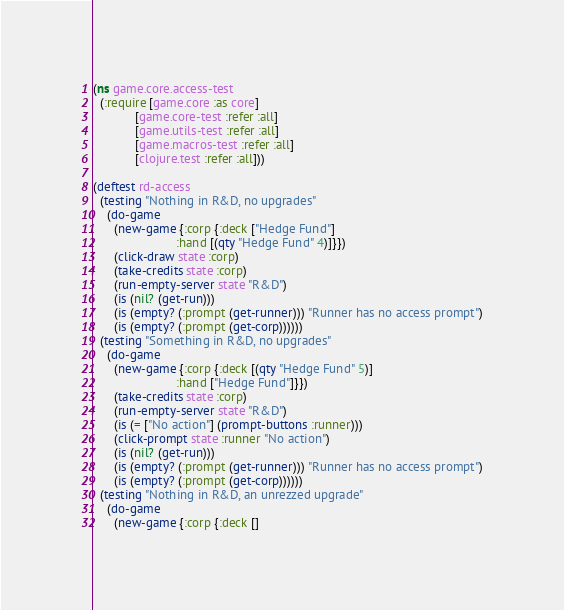<code> <loc_0><loc_0><loc_500><loc_500><_Clojure_>(ns game.core.access-test
  (:require [game.core :as core]
            [game.core-test :refer :all]
            [game.utils-test :refer :all]
            [game.macros-test :refer :all]
            [clojure.test :refer :all]))

(deftest rd-access
  (testing "Nothing in R&D, no upgrades"
    (do-game
      (new-game {:corp {:deck ["Hedge Fund"]
                        :hand [(qty "Hedge Fund" 4)]}})
      (click-draw state :corp)
      (take-credits state :corp)
      (run-empty-server state "R&D")
      (is (nil? (get-run)))
      (is (empty? (:prompt (get-runner))) "Runner has no access prompt")
      (is (empty? (:prompt (get-corp))))))
  (testing "Something in R&D, no upgrades"
    (do-game
      (new-game {:corp {:deck [(qty "Hedge Fund" 5)]
                        :hand ["Hedge Fund"]}})
      (take-credits state :corp)
      (run-empty-server state "R&D")
      (is (= ["No action"] (prompt-buttons :runner)))
      (click-prompt state :runner "No action")
      (is (nil? (get-run)))
      (is (empty? (:prompt (get-runner))) "Runner has no access prompt")
      (is (empty? (:prompt (get-corp))))))
  (testing "Nothing in R&D, an unrezzed upgrade"
    (do-game
      (new-game {:corp {:deck []</code> 